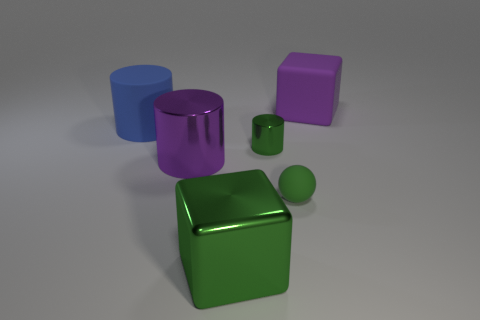What time of day would you say it is based on the lighting in the image? The image doesn't provide clear signs of natural lighting that would indicate a time of day; it seems to be a controlled environment with artificial lighting. The shadows are soft, and the illumination is uniform, suggesting an indoor photo shoot with studio lights. 